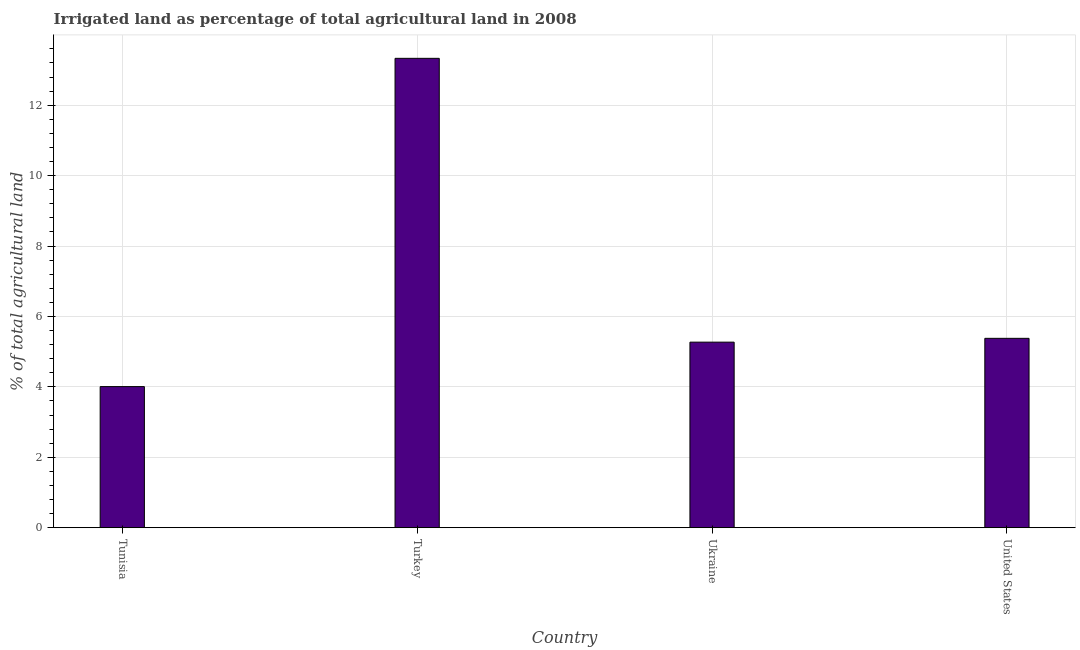Does the graph contain any zero values?
Provide a succinct answer. No. Does the graph contain grids?
Provide a succinct answer. Yes. What is the title of the graph?
Your response must be concise. Irrigated land as percentage of total agricultural land in 2008. What is the label or title of the Y-axis?
Make the answer very short. % of total agricultural land. What is the percentage of agricultural irrigated land in Ukraine?
Your response must be concise. 5.27. Across all countries, what is the maximum percentage of agricultural irrigated land?
Your answer should be very brief. 13.33. Across all countries, what is the minimum percentage of agricultural irrigated land?
Give a very brief answer. 4.01. In which country was the percentage of agricultural irrigated land maximum?
Offer a very short reply. Turkey. In which country was the percentage of agricultural irrigated land minimum?
Offer a very short reply. Tunisia. What is the sum of the percentage of agricultural irrigated land?
Your response must be concise. 27.99. What is the difference between the percentage of agricultural irrigated land in Turkey and Ukraine?
Your answer should be very brief. 8.06. What is the average percentage of agricultural irrigated land per country?
Provide a short and direct response. 7. What is the median percentage of agricultural irrigated land?
Provide a succinct answer. 5.32. What is the ratio of the percentage of agricultural irrigated land in Turkey to that in United States?
Make the answer very short. 2.48. Is the percentage of agricultural irrigated land in Ukraine less than that in United States?
Make the answer very short. Yes. What is the difference between the highest and the second highest percentage of agricultural irrigated land?
Your answer should be very brief. 7.95. What is the difference between the highest and the lowest percentage of agricultural irrigated land?
Your response must be concise. 9.32. In how many countries, is the percentage of agricultural irrigated land greater than the average percentage of agricultural irrigated land taken over all countries?
Offer a terse response. 1. How many bars are there?
Provide a short and direct response. 4. What is the % of total agricultural land of Tunisia?
Provide a succinct answer. 4.01. What is the % of total agricultural land in Turkey?
Keep it short and to the point. 13.33. What is the % of total agricultural land of Ukraine?
Your answer should be very brief. 5.27. What is the % of total agricultural land in United States?
Make the answer very short. 5.38. What is the difference between the % of total agricultural land in Tunisia and Turkey?
Offer a terse response. -9.32. What is the difference between the % of total agricultural land in Tunisia and Ukraine?
Provide a succinct answer. -1.26. What is the difference between the % of total agricultural land in Tunisia and United States?
Offer a very short reply. -1.37. What is the difference between the % of total agricultural land in Turkey and Ukraine?
Make the answer very short. 8.06. What is the difference between the % of total agricultural land in Turkey and United States?
Offer a very short reply. 7.95. What is the difference between the % of total agricultural land in Ukraine and United States?
Make the answer very short. -0.11. What is the ratio of the % of total agricultural land in Tunisia to that in Turkey?
Your response must be concise. 0.3. What is the ratio of the % of total agricultural land in Tunisia to that in Ukraine?
Offer a terse response. 0.76. What is the ratio of the % of total agricultural land in Tunisia to that in United States?
Ensure brevity in your answer.  0.74. What is the ratio of the % of total agricultural land in Turkey to that in Ukraine?
Provide a succinct answer. 2.53. What is the ratio of the % of total agricultural land in Turkey to that in United States?
Provide a short and direct response. 2.48. 